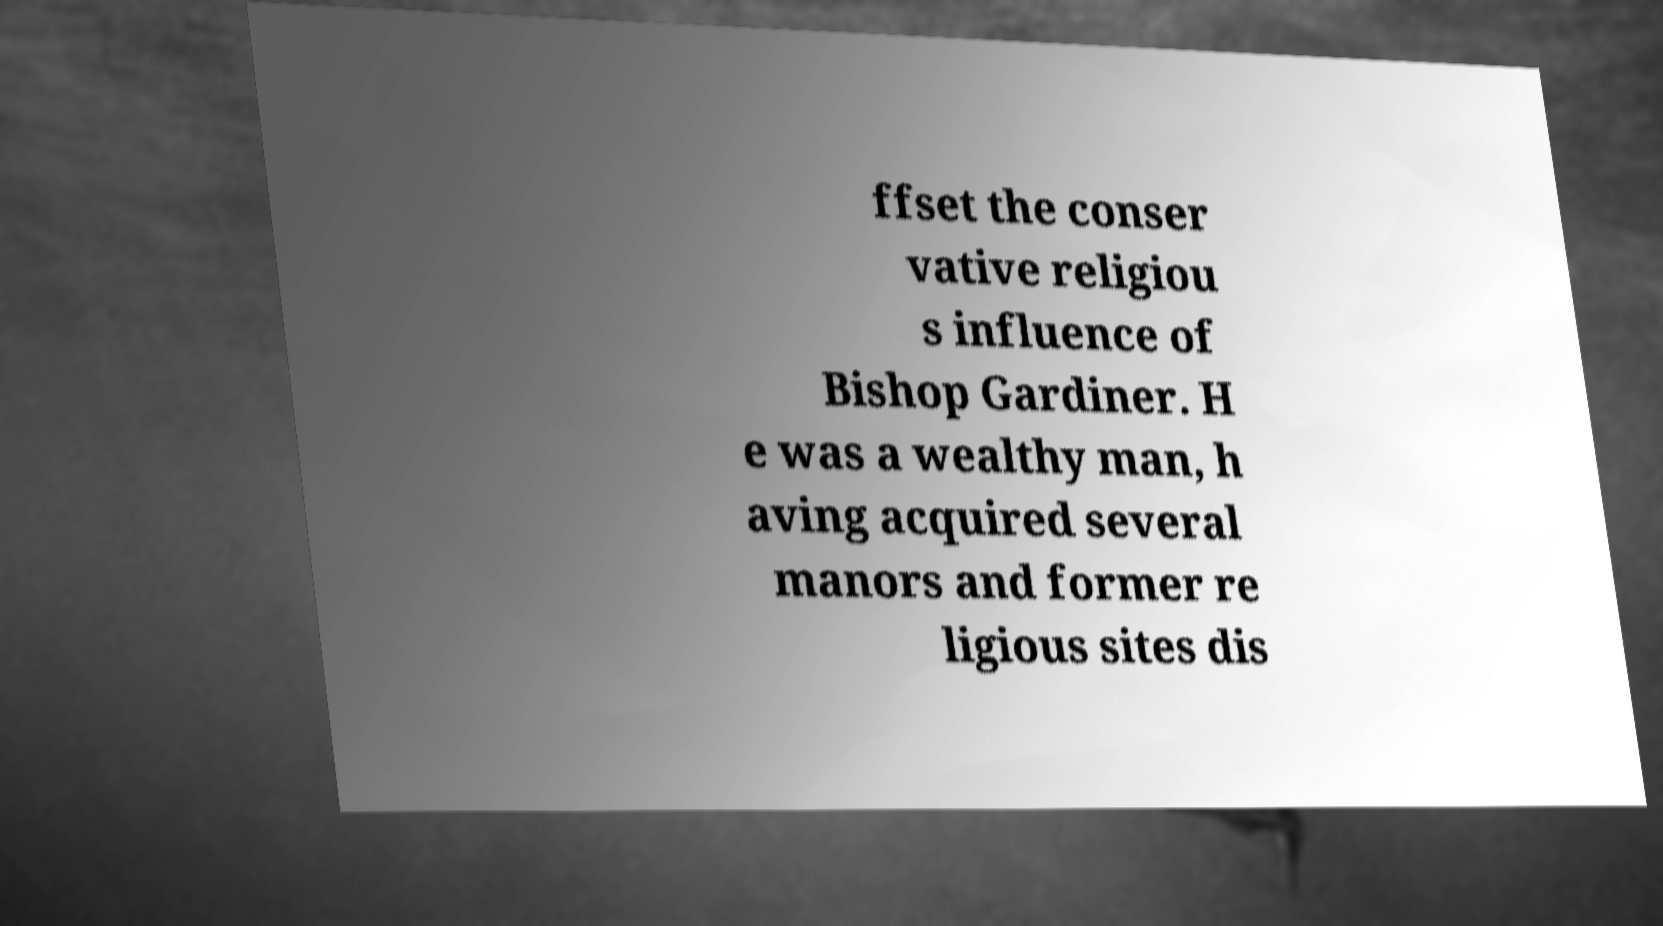Can you accurately transcribe the text from the provided image for me? ffset the conser vative religiou s influence of Bishop Gardiner. H e was a wealthy man, h aving acquired several manors and former re ligious sites dis 